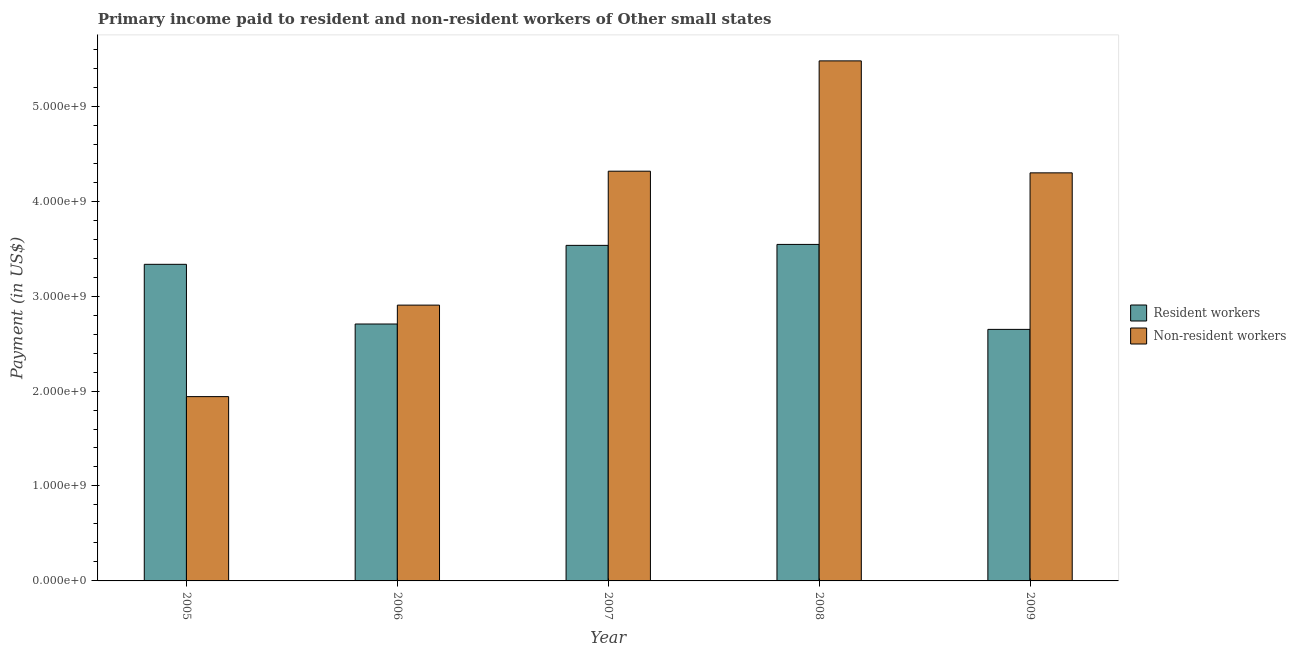How many different coloured bars are there?
Your answer should be compact. 2. How many bars are there on the 4th tick from the right?
Make the answer very short. 2. What is the payment made to non-resident workers in 2005?
Provide a short and direct response. 1.94e+09. Across all years, what is the maximum payment made to non-resident workers?
Your response must be concise. 5.48e+09. Across all years, what is the minimum payment made to resident workers?
Your answer should be very brief. 2.65e+09. In which year was the payment made to resident workers maximum?
Your answer should be compact. 2008. In which year was the payment made to resident workers minimum?
Offer a terse response. 2009. What is the total payment made to non-resident workers in the graph?
Your answer should be very brief. 1.89e+1. What is the difference between the payment made to resident workers in 2007 and that in 2008?
Your response must be concise. -9.98e+06. What is the difference between the payment made to resident workers in 2005 and the payment made to non-resident workers in 2006?
Provide a succinct answer. 6.29e+08. What is the average payment made to non-resident workers per year?
Your response must be concise. 3.79e+09. In the year 2007, what is the difference between the payment made to non-resident workers and payment made to resident workers?
Provide a succinct answer. 0. What is the ratio of the payment made to resident workers in 2008 to that in 2009?
Keep it short and to the point. 1.34. What is the difference between the highest and the second highest payment made to resident workers?
Your response must be concise. 9.98e+06. What is the difference between the highest and the lowest payment made to resident workers?
Give a very brief answer. 8.95e+08. What does the 1st bar from the left in 2009 represents?
Your answer should be very brief. Resident workers. What does the 2nd bar from the right in 2006 represents?
Provide a succinct answer. Resident workers. How many bars are there?
Offer a very short reply. 10. What is the title of the graph?
Your answer should be very brief. Primary income paid to resident and non-resident workers of Other small states. What is the label or title of the X-axis?
Give a very brief answer. Year. What is the label or title of the Y-axis?
Your response must be concise. Payment (in US$). What is the Payment (in US$) in Resident workers in 2005?
Give a very brief answer. 3.33e+09. What is the Payment (in US$) of Non-resident workers in 2005?
Give a very brief answer. 1.94e+09. What is the Payment (in US$) of Resident workers in 2006?
Provide a succinct answer. 2.71e+09. What is the Payment (in US$) in Non-resident workers in 2006?
Ensure brevity in your answer.  2.90e+09. What is the Payment (in US$) of Resident workers in 2007?
Offer a very short reply. 3.53e+09. What is the Payment (in US$) of Non-resident workers in 2007?
Ensure brevity in your answer.  4.32e+09. What is the Payment (in US$) of Resident workers in 2008?
Your answer should be compact. 3.54e+09. What is the Payment (in US$) in Non-resident workers in 2008?
Give a very brief answer. 5.48e+09. What is the Payment (in US$) of Resident workers in 2009?
Ensure brevity in your answer.  2.65e+09. What is the Payment (in US$) of Non-resident workers in 2009?
Your response must be concise. 4.30e+09. Across all years, what is the maximum Payment (in US$) in Resident workers?
Offer a terse response. 3.54e+09. Across all years, what is the maximum Payment (in US$) in Non-resident workers?
Your answer should be very brief. 5.48e+09. Across all years, what is the minimum Payment (in US$) in Resident workers?
Ensure brevity in your answer.  2.65e+09. Across all years, what is the minimum Payment (in US$) in Non-resident workers?
Provide a short and direct response. 1.94e+09. What is the total Payment (in US$) of Resident workers in the graph?
Your answer should be compact. 1.58e+1. What is the total Payment (in US$) in Non-resident workers in the graph?
Make the answer very short. 1.89e+1. What is the difference between the Payment (in US$) in Resident workers in 2005 and that in 2006?
Ensure brevity in your answer.  6.29e+08. What is the difference between the Payment (in US$) of Non-resident workers in 2005 and that in 2006?
Offer a terse response. -9.64e+08. What is the difference between the Payment (in US$) of Resident workers in 2005 and that in 2007?
Provide a short and direct response. -2.00e+08. What is the difference between the Payment (in US$) in Non-resident workers in 2005 and that in 2007?
Give a very brief answer. -2.37e+09. What is the difference between the Payment (in US$) of Resident workers in 2005 and that in 2008?
Provide a succinct answer. -2.10e+08. What is the difference between the Payment (in US$) of Non-resident workers in 2005 and that in 2008?
Provide a short and direct response. -3.54e+09. What is the difference between the Payment (in US$) in Resident workers in 2005 and that in 2009?
Your answer should be very brief. 6.85e+08. What is the difference between the Payment (in US$) in Non-resident workers in 2005 and that in 2009?
Your answer should be compact. -2.36e+09. What is the difference between the Payment (in US$) of Resident workers in 2006 and that in 2007?
Ensure brevity in your answer.  -8.28e+08. What is the difference between the Payment (in US$) of Non-resident workers in 2006 and that in 2007?
Ensure brevity in your answer.  -1.41e+09. What is the difference between the Payment (in US$) of Resident workers in 2006 and that in 2008?
Your answer should be very brief. -8.38e+08. What is the difference between the Payment (in US$) in Non-resident workers in 2006 and that in 2008?
Offer a very short reply. -2.57e+09. What is the difference between the Payment (in US$) of Resident workers in 2006 and that in 2009?
Your answer should be compact. 5.66e+07. What is the difference between the Payment (in US$) of Non-resident workers in 2006 and that in 2009?
Offer a very short reply. -1.39e+09. What is the difference between the Payment (in US$) of Resident workers in 2007 and that in 2008?
Make the answer very short. -9.98e+06. What is the difference between the Payment (in US$) of Non-resident workers in 2007 and that in 2008?
Ensure brevity in your answer.  -1.16e+09. What is the difference between the Payment (in US$) in Resident workers in 2007 and that in 2009?
Your answer should be compact. 8.85e+08. What is the difference between the Payment (in US$) of Non-resident workers in 2007 and that in 2009?
Your answer should be compact. 1.75e+07. What is the difference between the Payment (in US$) in Resident workers in 2008 and that in 2009?
Your answer should be very brief. 8.95e+08. What is the difference between the Payment (in US$) of Non-resident workers in 2008 and that in 2009?
Provide a succinct answer. 1.18e+09. What is the difference between the Payment (in US$) in Resident workers in 2005 and the Payment (in US$) in Non-resident workers in 2006?
Provide a short and direct response. 4.30e+08. What is the difference between the Payment (in US$) of Resident workers in 2005 and the Payment (in US$) of Non-resident workers in 2007?
Give a very brief answer. -9.81e+08. What is the difference between the Payment (in US$) of Resident workers in 2005 and the Payment (in US$) of Non-resident workers in 2008?
Your answer should be compact. -2.14e+09. What is the difference between the Payment (in US$) of Resident workers in 2005 and the Payment (in US$) of Non-resident workers in 2009?
Provide a succinct answer. -9.63e+08. What is the difference between the Payment (in US$) of Resident workers in 2006 and the Payment (in US$) of Non-resident workers in 2007?
Ensure brevity in your answer.  -1.61e+09. What is the difference between the Payment (in US$) of Resident workers in 2006 and the Payment (in US$) of Non-resident workers in 2008?
Provide a succinct answer. -2.77e+09. What is the difference between the Payment (in US$) in Resident workers in 2006 and the Payment (in US$) in Non-resident workers in 2009?
Offer a terse response. -1.59e+09. What is the difference between the Payment (in US$) of Resident workers in 2007 and the Payment (in US$) of Non-resident workers in 2008?
Provide a succinct answer. -1.94e+09. What is the difference between the Payment (in US$) of Resident workers in 2007 and the Payment (in US$) of Non-resident workers in 2009?
Offer a very short reply. -7.64e+08. What is the difference between the Payment (in US$) of Resident workers in 2008 and the Payment (in US$) of Non-resident workers in 2009?
Ensure brevity in your answer.  -7.54e+08. What is the average Payment (in US$) in Resident workers per year?
Offer a very short reply. 3.15e+09. What is the average Payment (in US$) in Non-resident workers per year?
Your answer should be very brief. 3.79e+09. In the year 2005, what is the difference between the Payment (in US$) in Resident workers and Payment (in US$) in Non-resident workers?
Provide a short and direct response. 1.39e+09. In the year 2006, what is the difference between the Payment (in US$) in Resident workers and Payment (in US$) in Non-resident workers?
Provide a short and direct response. -1.99e+08. In the year 2007, what is the difference between the Payment (in US$) in Resident workers and Payment (in US$) in Non-resident workers?
Provide a short and direct response. -7.81e+08. In the year 2008, what is the difference between the Payment (in US$) in Resident workers and Payment (in US$) in Non-resident workers?
Give a very brief answer. -1.93e+09. In the year 2009, what is the difference between the Payment (in US$) in Resident workers and Payment (in US$) in Non-resident workers?
Provide a short and direct response. -1.65e+09. What is the ratio of the Payment (in US$) in Resident workers in 2005 to that in 2006?
Ensure brevity in your answer.  1.23. What is the ratio of the Payment (in US$) of Non-resident workers in 2005 to that in 2006?
Offer a very short reply. 0.67. What is the ratio of the Payment (in US$) of Resident workers in 2005 to that in 2007?
Offer a terse response. 0.94. What is the ratio of the Payment (in US$) in Non-resident workers in 2005 to that in 2007?
Offer a terse response. 0.45. What is the ratio of the Payment (in US$) of Resident workers in 2005 to that in 2008?
Give a very brief answer. 0.94. What is the ratio of the Payment (in US$) of Non-resident workers in 2005 to that in 2008?
Your response must be concise. 0.35. What is the ratio of the Payment (in US$) in Resident workers in 2005 to that in 2009?
Your response must be concise. 1.26. What is the ratio of the Payment (in US$) in Non-resident workers in 2005 to that in 2009?
Keep it short and to the point. 0.45. What is the ratio of the Payment (in US$) in Resident workers in 2006 to that in 2007?
Make the answer very short. 0.77. What is the ratio of the Payment (in US$) of Non-resident workers in 2006 to that in 2007?
Ensure brevity in your answer.  0.67. What is the ratio of the Payment (in US$) in Resident workers in 2006 to that in 2008?
Ensure brevity in your answer.  0.76. What is the ratio of the Payment (in US$) of Non-resident workers in 2006 to that in 2008?
Offer a terse response. 0.53. What is the ratio of the Payment (in US$) of Resident workers in 2006 to that in 2009?
Provide a short and direct response. 1.02. What is the ratio of the Payment (in US$) in Non-resident workers in 2006 to that in 2009?
Your response must be concise. 0.68. What is the ratio of the Payment (in US$) in Resident workers in 2007 to that in 2008?
Your response must be concise. 1. What is the ratio of the Payment (in US$) in Non-resident workers in 2007 to that in 2008?
Keep it short and to the point. 0.79. What is the ratio of the Payment (in US$) in Resident workers in 2007 to that in 2009?
Your answer should be compact. 1.33. What is the ratio of the Payment (in US$) of Resident workers in 2008 to that in 2009?
Make the answer very short. 1.34. What is the ratio of the Payment (in US$) in Non-resident workers in 2008 to that in 2009?
Offer a terse response. 1.27. What is the difference between the highest and the second highest Payment (in US$) of Resident workers?
Ensure brevity in your answer.  9.98e+06. What is the difference between the highest and the second highest Payment (in US$) of Non-resident workers?
Keep it short and to the point. 1.16e+09. What is the difference between the highest and the lowest Payment (in US$) of Resident workers?
Give a very brief answer. 8.95e+08. What is the difference between the highest and the lowest Payment (in US$) of Non-resident workers?
Provide a succinct answer. 3.54e+09. 